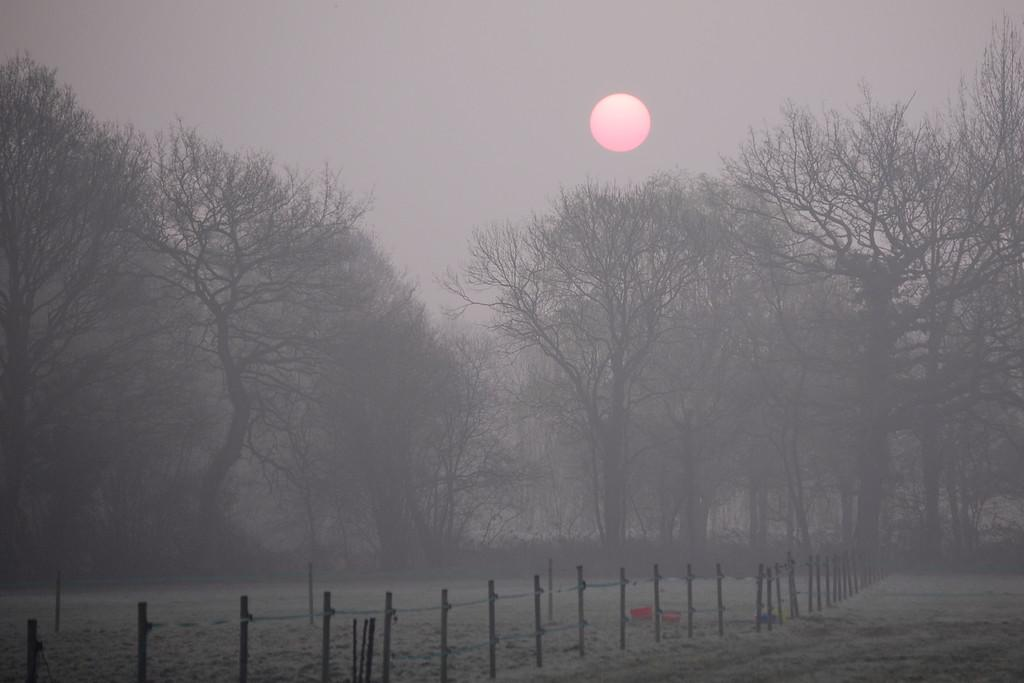What type of surface can be seen in the image? There is ground visible in the image. What structures are present in the image? There are poles in the image. What type of vegetation is in the image? There are trees in the image. What celestial body is visible in the background of the image? The sun is visible in the background of the image. What type of behavior can be observed in the stream in the image? There is no stream present in the image, so no behavior can be observed. 